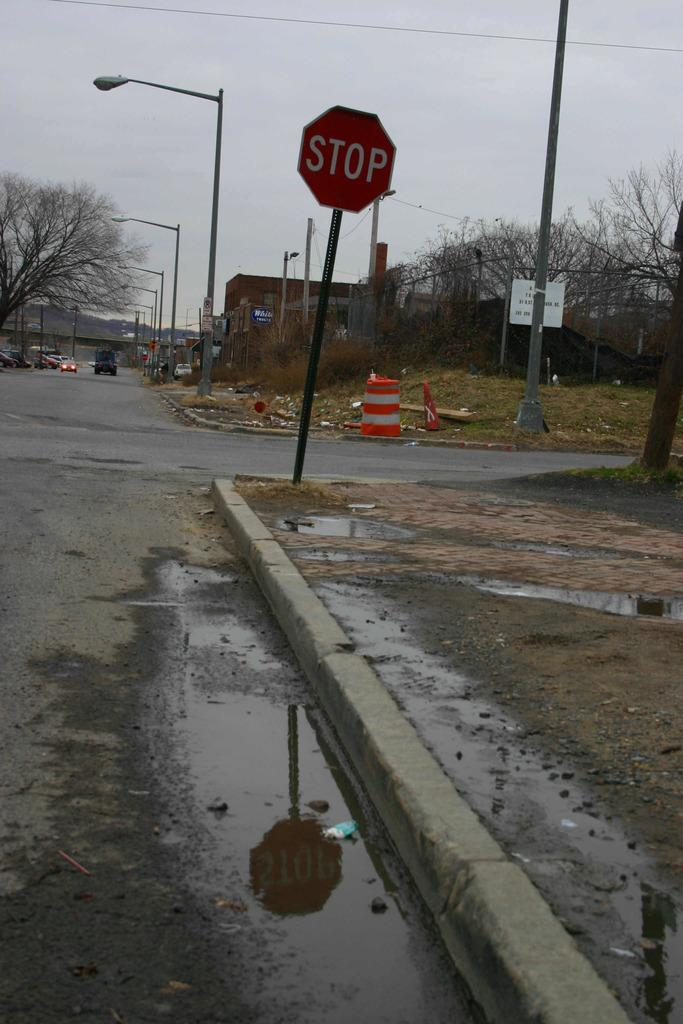<image>
Share a concise interpretation of the image provided. A stop sign stands leaning slightly on a dirty and wet street corner. 